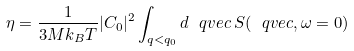Convert formula to latex. <formula><loc_0><loc_0><loc_500><loc_500>\eta = \frac { 1 } { 3 M k _ { B } T } | C _ { 0 } | ^ { 2 } \int _ { q < q _ { 0 } } d \ q v e c \, S ( \ q v e c , \omega = 0 )</formula> 